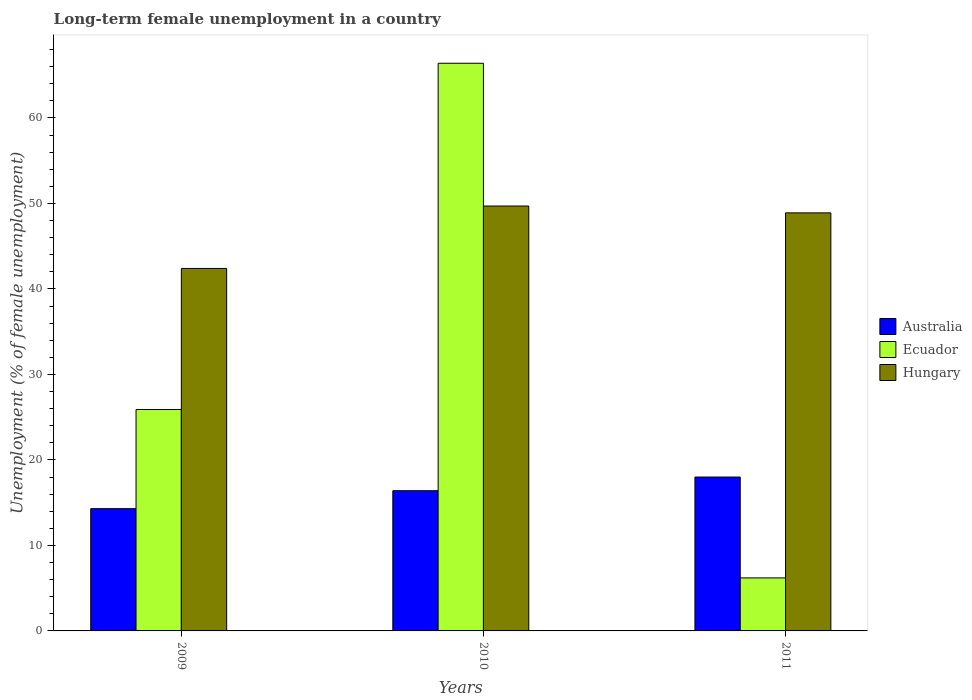How many groups of bars are there?
Offer a very short reply. 3. Are the number of bars per tick equal to the number of legend labels?
Offer a terse response. Yes. Are the number of bars on each tick of the X-axis equal?
Make the answer very short. Yes. What is the label of the 1st group of bars from the left?
Provide a short and direct response. 2009. In how many cases, is the number of bars for a given year not equal to the number of legend labels?
Make the answer very short. 0. What is the percentage of long-term unemployed female population in Australia in 2010?
Offer a terse response. 16.4. Across all years, what is the maximum percentage of long-term unemployed female population in Hungary?
Offer a very short reply. 49.7. Across all years, what is the minimum percentage of long-term unemployed female population in Hungary?
Your answer should be compact. 42.4. What is the total percentage of long-term unemployed female population in Australia in the graph?
Make the answer very short. 48.7. What is the difference between the percentage of long-term unemployed female population in Ecuador in 2009 and that in 2010?
Provide a short and direct response. -40.5. What is the difference between the percentage of long-term unemployed female population in Australia in 2011 and the percentage of long-term unemployed female population in Hungary in 2009?
Your response must be concise. -24.4. What is the average percentage of long-term unemployed female population in Hungary per year?
Make the answer very short. 47. In the year 2011, what is the difference between the percentage of long-term unemployed female population in Australia and percentage of long-term unemployed female population in Ecuador?
Make the answer very short. 11.8. What is the ratio of the percentage of long-term unemployed female population in Hungary in 2009 to that in 2011?
Provide a short and direct response. 0.87. Is the percentage of long-term unemployed female population in Hungary in 2010 less than that in 2011?
Make the answer very short. No. What is the difference between the highest and the second highest percentage of long-term unemployed female population in Ecuador?
Ensure brevity in your answer.  40.5. What is the difference between the highest and the lowest percentage of long-term unemployed female population in Australia?
Keep it short and to the point. 3.7. Is the sum of the percentage of long-term unemployed female population in Ecuador in 2009 and 2011 greater than the maximum percentage of long-term unemployed female population in Hungary across all years?
Provide a short and direct response. No. What does the 3rd bar from the right in 2010 represents?
Keep it short and to the point. Australia. Is it the case that in every year, the sum of the percentage of long-term unemployed female population in Hungary and percentage of long-term unemployed female population in Australia is greater than the percentage of long-term unemployed female population in Ecuador?
Your answer should be very brief. No. How many bars are there?
Offer a terse response. 9. Are all the bars in the graph horizontal?
Your response must be concise. No. How many years are there in the graph?
Offer a terse response. 3. What is the difference between two consecutive major ticks on the Y-axis?
Your response must be concise. 10. Where does the legend appear in the graph?
Your answer should be compact. Center right. How are the legend labels stacked?
Your response must be concise. Vertical. What is the title of the graph?
Your answer should be very brief. Long-term female unemployment in a country. Does "Cameroon" appear as one of the legend labels in the graph?
Ensure brevity in your answer.  No. What is the label or title of the X-axis?
Your answer should be very brief. Years. What is the label or title of the Y-axis?
Your response must be concise. Unemployment (% of female unemployment). What is the Unemployment (% of female unemployment) in Australia in 2009?
Keep it short and to the point. 14.3. What is the Unemployment (% of female unemployment) in Ecuador in 2009?
Your answer should be compact. 25.9. What is the Unemployment (% of female unemployment) of Hungary in 2009?
Give a very brief answer. 42.4. What is the Unemployment (% of female unemployment) of Australia in 2010?
Ensure brevity in your answer.  16.4. What is the Unemployment (% of female unemployment) of Ecuador in 2010?
Provide a succinct answer. 66.4. What is the Unemployment (% of female unemployment) of Hungary in 2010?
Offer a terse response. 49.7. What is the Unemployment (% of female unemployment) of Ecuador in 2011?
Make the answer very short. 6.2. What is the Unemployment (% of female unemployment) of Hungary in 2011?
Your answer should be compact. 48.9. Across all years, what is the maximum Unemployment (% of female unemployment) of Australia?
Keep it short and to the point. 18. Across all years, what is the maximum Unemployment (% of female unemployment) of Ecuador?
Provide a short and direct response. 66.4. Across all years, what is the maximum Unemployment (% of female unemployment) of Hungary?
Your answer should be compact. 49.7. Across all years, what is the minimum Unemployment (% of female unemployment) in Australia?
Provide a short and direct response. 14.3. Across all years, what is the minimum Unemployment (% of female unemployment) of Ecuador?
Ensure brevity in your answer.  6.2. Across all years, what is the minimum Unemployment (% of female unemployment) of Hungary?
Offer a terse response. 42.4. What is the total Unemployment (% of female unemployment) in Australia in the graph?
Provide a short and direct response. 48.7. What is the total Unemployment (% of female unemployment) of Ecuador in the graph?
Make the answer very short. 98.5. What is the total Unemployment (% of female unemployment) of Hungary in the graph?
Provide a succinct answer. 141. What is the difference between the Unemployment (% of female unemployment) of Australia in 2009 and that in 2010?
Your response must be concise. -2.1. What is the difference between the Unemployment (% of female unemployment) of Ecuador in 2009 and that in 2010?
Keep it short and to the point. -40.5. What is the difference between the Unemployment (% of female unemployment) in Ecuador in 2009 and that in 2011?
Your response must be concise. 19.7. What is the difference between the Unemployment (% of female unemployment) of Hungary in 2009 and that in 2011?
Make the answer very short. -6.5. What is the difference between the Unemployment (% of female unemployment) of Ecuador in 2010 and that in 2011?
Ensure brevity in your answer.  60.2. What is the difference between the Unemployment (% of female unemployment) in Australia in 2009 and the Unemployment (% of female unemployment) in Ecuador in 2010?
Your response must be concise. -52.1. What is the difference between the Unemployment (% of female unemployment) in Australia in 2009 and the Unemployment (% of female unemployment) in Hungary in 2010?
Offer a very short reply. -35.4. What is the difference between the Unemployment (% of female unemployment) in Ecuador in 2009 and the Unemployment (% of female unemployment) in Hungary in 2010?
Ensure brevity in your answer.  -23.8. What is the difference between the Unemployment (% of female unemployment) of Australia in 2009 and the Unemployment (% of female unemployment) of Hungary in 2011?
Provide a succinct answer. -34.6. What is the difference between the Unemployment (% of female unemployment) in Ecuador in 2009 and the Unemployment (% of female unemployment) in Hungary in 2011?
Offer a terse response. -23. What is the difference between the Unemployment (% of female unemployment) of Australia in 2010 and the Unemployment (% of female unemployment) of Ecuador in 2011?
Your response must be concise. 10.2. What is the difference between the Unemployment (% of female unemployment) in Australia in 2010 and the Unemployment (% of female unemployment) in Hungary in 2011?
Offer a terse response. -32.5. What is the average Unemployment (% of female unemployment) of Australia per year?
Your answer should be very brief. 16.23. What is the average Unemployment (% of female unemployment) of Ecuador per year?
Offer a very short reply. 32.83. In the year 2009, what is the difference between the Unemployment (% of female unemployment) of Australia and Unemployment (% of female unemployment) of Ecuador?
Offer a terse response. -11.6. In the year 2009, what is the difference between the Unemployment (% of female unemployment) of Australia and Unemployment (% of female unemployment) of Hungary?
Offer a very short reply. -28.1. In the year 2009, what is the difference between the Unemployment (% of female unemployment) in Ecuador and Unemployment (% of female unemployment) in Hungary?
Provide a succinct answer. -16.5. In the year 2010, what is the difference between the Unemployment (% of female unemployment) of Australia and Unemployment (% of female unemployment) of Hungary?
Your response must be concise. -33.3. In the year 2010, what is the difference between the Unemployment (% of female unemployment) in Ecuador and Unemployment (% of female unemployment) in Hungary?
Offer a very short reply. 16.7. In the year 2011, what is the difference between the Unemployment (% of female unemployment) in Australia and Unemployment (% of female unemployment) in Ecuador?
Provide a short and direct response. 11.8. In the year 2011, what is the difference between the Unemployment (% of female unemployment) in Australia and Unemployment (% of female unemployment) in Hungary?
Make the answer very short. -30.9. In the year 2011, what is the difference between the Unemployment (% of female unemployment) of Ecuador and Unemployment (% of female unemployment) of Hungary?
Your answer should be compact. -42.7. What is the ratio of the Unemployment (% of female unemployment) in Australia in 2009 to that in 2010?
Ensure brevity in your answer.  0.87. What is the ratio of the Unemployment (% of female unemployment) in Ecuador in 2009 to that in 2010?
Ensure brevity in your answer.  0.39. What is the ratio of the Unemployment (% of female unemployment) in Hungary in 2009 to that in 2010?
Provide a short and direct response. 0.85. What is the ratio of the Unemployment (% of female unemployment) in Australia in 2009 to that in 2011?
Provide a succinct answer. 0.79. What is the ratio of the Unemployment (% of female unemployment) of Ecuador in 2009 to that in 2011?
Offer a very short reply. 4.18. What is the ratio of the Unemployment (% of female unemployment) in Hungary in 2009 to that in 2011?
Ensure brevity in your answer.  0.87. What is the ratio of the Unemployment (% of female unemployment) of Australia in 2010 to that in 2011?
Make the answer very short. 0.91. What is the ratio of the Unemployment (% of female unemployment) of Ecuador in 2010 to that in 2011?
Provide a short and direct response. 10.71. What is the ratio of the Unemployment (% of female unemployment) in Hungary in 2010 to that in 2011?
Your answer should be very brief. 1.02. What is the difference between the highest and the second highest Unemployment (% of female unemployment) in Australia?
Your answer should be compact. 1.6. What is the difference between the highest and the second highest Unemployment (% of female unemployment) in Ecuador?
Your response must be concise. 40.5. What is the difference between the highest and the second highest Unemployment (% of female unemployment) of Hungary?
Your response must be concise. 0.8. What is the difference between the highest and the lowest Unemployment (% of female unemployment) of Ecuador?
Offer a terse response. 60.2. 